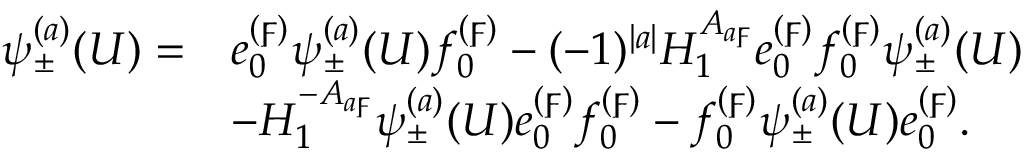Convert formula to latex. <formula><loc_0><loc_0><loc_500><loc_500>\begin{array} { r l } { \psi _ { \pm } ^ { ( a ) } ( U ) = } & { e _ { 0 } ^ { ( \digamma ) } \psi _ { \pm } ^ { ( a ) } ( U ) f _ { 0 } ^ { ( \digamma ) } - ( - 1 ) ^ { | a | } H _ { 1 } ^ { A _ { a \digamma } } e _ { 0 } ^ { ( \digamma ) } f _ { 0 } ^ { ( \digamma ) } \psi _ { \pm } ^ { ( a ) } ( U ) } \\ & { - H _ { 1 } ^ { - A _ { a \digamma } } \psi _ { \pm } ^ { ( a ) } ( U ) e _ { 0 } ^ { ( \digamma ) } f _ { 0 } ^ { ( \digamma ) } - f _ { 0 } ^ { ( \digamma ) } \psi _ { \pm } ^ { ( a ) } ( U ) e _ { 0 } ^ { ( \digamma ) } . } \end{array}</formula> 